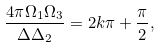Convert formula to latex. <formula><loc_0><loc_0><loc_500><loc_500>\frac { 4 \pi \Omega _ { 1 } \Omega _ { 3 } } { \Delta \Delta _ { 2 } } = 2 k \pi + \frac { \pi } { 2 } ,</formula> 